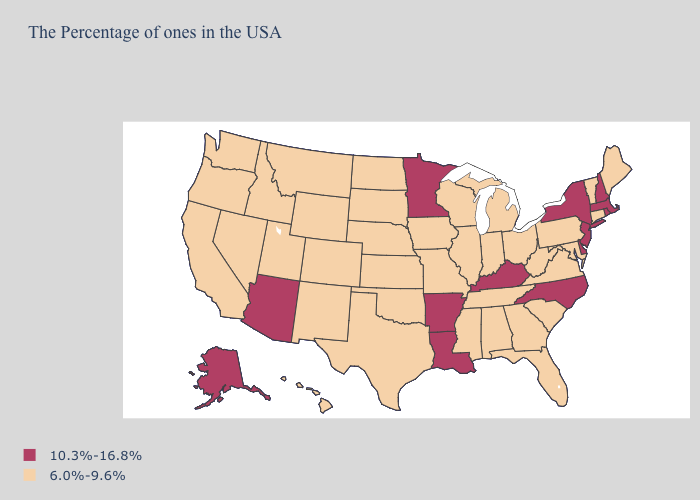What is the value of Louisiana?
Quick response, please. 10.3%-16.8%. What is the highest value in states that border Connecticut?
Answer briefly. 10.3%-16.8%. What is the value of Nevada?
Answer briefly. 6.0%-9.6%. Name the states that have a value in the range 6.0%-9.6%?
Write a very short answer. Maine, Vermont, Connecticut, Maryland, Pennsylvania, Virginia, South Carolina, West Virginia, Ohio, Florida, Georgia, Michigan, Indiana, Alabama, Tennessee, Wisconsin, Illinois, Mississippi, Missouri, Iowa, Kansas, Nebraska, Oklahoma, Texas, South Dakota, North Dakota, Wyoming, Colorado, New Mexico, Utah, Montana, Idaho, Nevada, California, Washington, Oregon, Hawaii. What is the lowest value in the USA?
Keep it brief. 6.0%-9.6%. Name the states that have a value in the range 10.3%-16.8%?
Be succinct. Massachusetts, Rhode Island, New Hampshire, New York, New Jersey, Delaware, North Carolina, Kentucky, Louisiana, Arkansas, Minnesota, Arizona, Alaska. Name the states that have a value in the range 10.3%-16.8%?
Answer briefly. Massachusetts, Rhode Island, New Hampshire, New York, New Jersey, Delaware, North Carolina, Kentucky, Louisiana, Arkansas, Minnesota, Arizona, Alaska. Does Louisiana have the highest value in the USA?
Give a very brief answer. Yes. Name the states that have a value in the range 10.3%-16.8%?
Write a very short answer. Massachusetts, Rhode Island, New Hampshire, New York, New Jersey, Delaware, North Carolina, Kentucky, Louisiana, Arkansas, Minnesota, Arizona, Alaska. Name the states that have a value in the range 6.0%-9.6%?
Be succinct. Maine, Vermont, Connecticut, Maryland, Pennsylvania, Virginia, South Carolina, West Virginia, Ohio, Florida, Georgia, Michigan, Indiana, Alabama, Tennessee, Wisconsin, Illinois, Mississippi, Missouri, Iowa, Kansas, Nebraska, Oklahoma, Texas, South Dakota, North Dakota, Wyoming, Colorado, New Mexico, Utah, Montana, Idaho, Nevada, California, Washington, Oregon, Hawaii. Which states have the highest value in the USA?
Answer briefly. Massachusetts, Rhode Island, New Hampshire, New York, New Jersey, Delaware, North Carolina, Kentucky, Louisiana, Arkansas, Minnesota, Arizona, Alaska. Does Mississippi have the highest value in the USA?
Give a very brief answer. No. What is the value of Florida?
Short answer required. 6.0%-9.6%. Is the legend a continuous bar?
Keep it brief. No. Name the states that have a value in the range 6.0%-9.6%?
Answer briefly. Maine, Vermont, Connecticut, Maryland, Pennsylvania, Virginia, South Carolina, West Virginia, Ohio, Florida, Georgia, Michigan, Indiana, Alabama, Tennessee, Wisconsin, Illinois, Mississippi, Missouri, Iowa, Kansas, Nebraska, Oklahoma, Texas, South Dakota, North Dakota, Wyoming, Colorado, New Mexico, Utah, Montana, Idaho, Nevada, California, Washington, Oregon, Hawaii. 